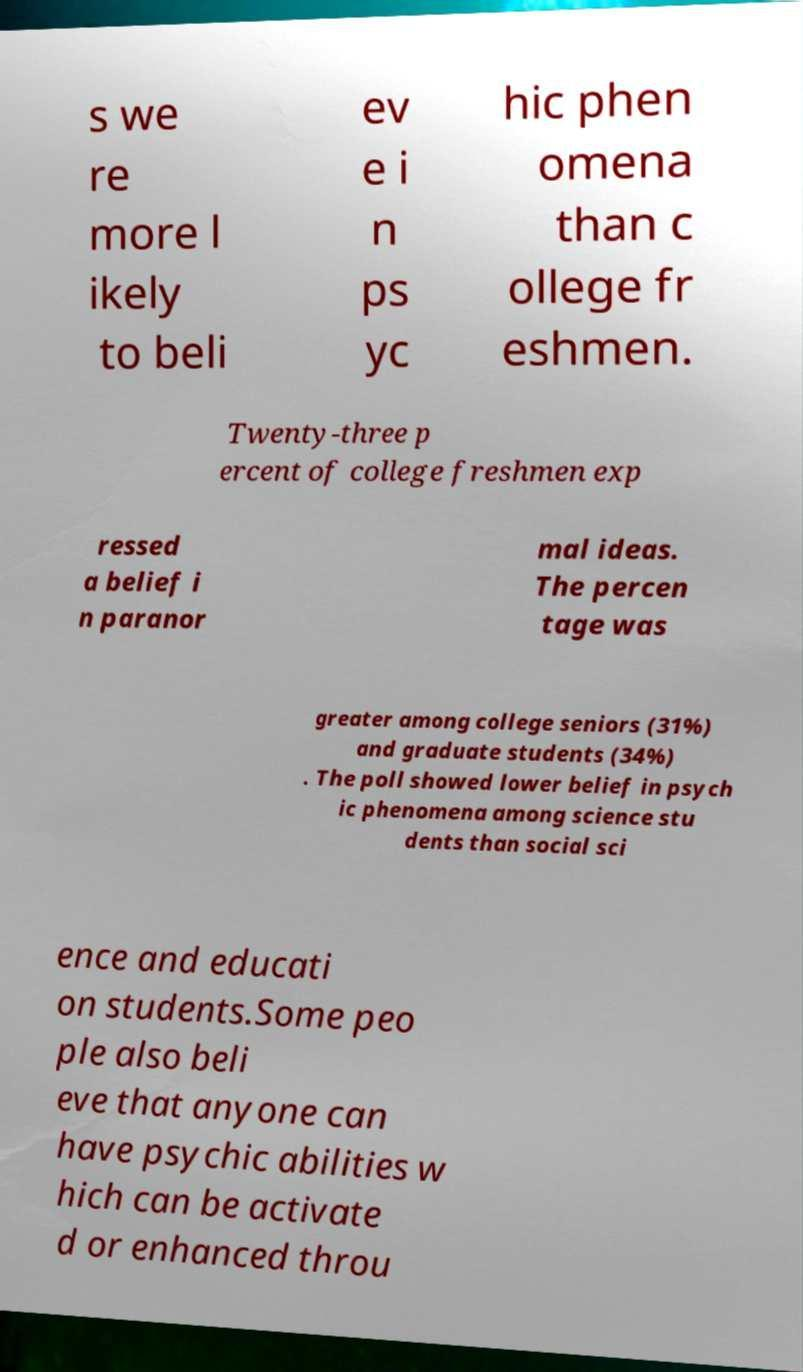Please read and relay the text visible in this image. What does it say? s we re more l ikely to beli ev e i n ps yc hic phen omena than c ollege fr eshmen. Twenty-three p ercent of college freshmen exp ressed a belief i n paranor mal ideas. The percen tage was greater among college seniors (31%) and graduate students (34%) . The poll showed lower belief in psych ic phenomena among science stu dents than social sci ence and educati on students.Some peo ple also beli eve that anyone can have psychic abilities w hich can be activate d or enhanced throu 